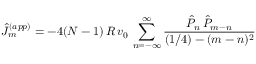<formula> <loc_0><loc_0><loc_500><loc_500>\hat { J } _ { m } ^ { ( a p p ) } = - 4 ( N - 1 ) \, R \, v _ { 0 } \, \sum _ { n = - \infty } ^ { \infty } { \frac { \hat { P } _ { n } \, \hat { P } _ { m - n } } { ( 1 / 4 ) - ( m - n ) ^ { 2 } } }</formula> 